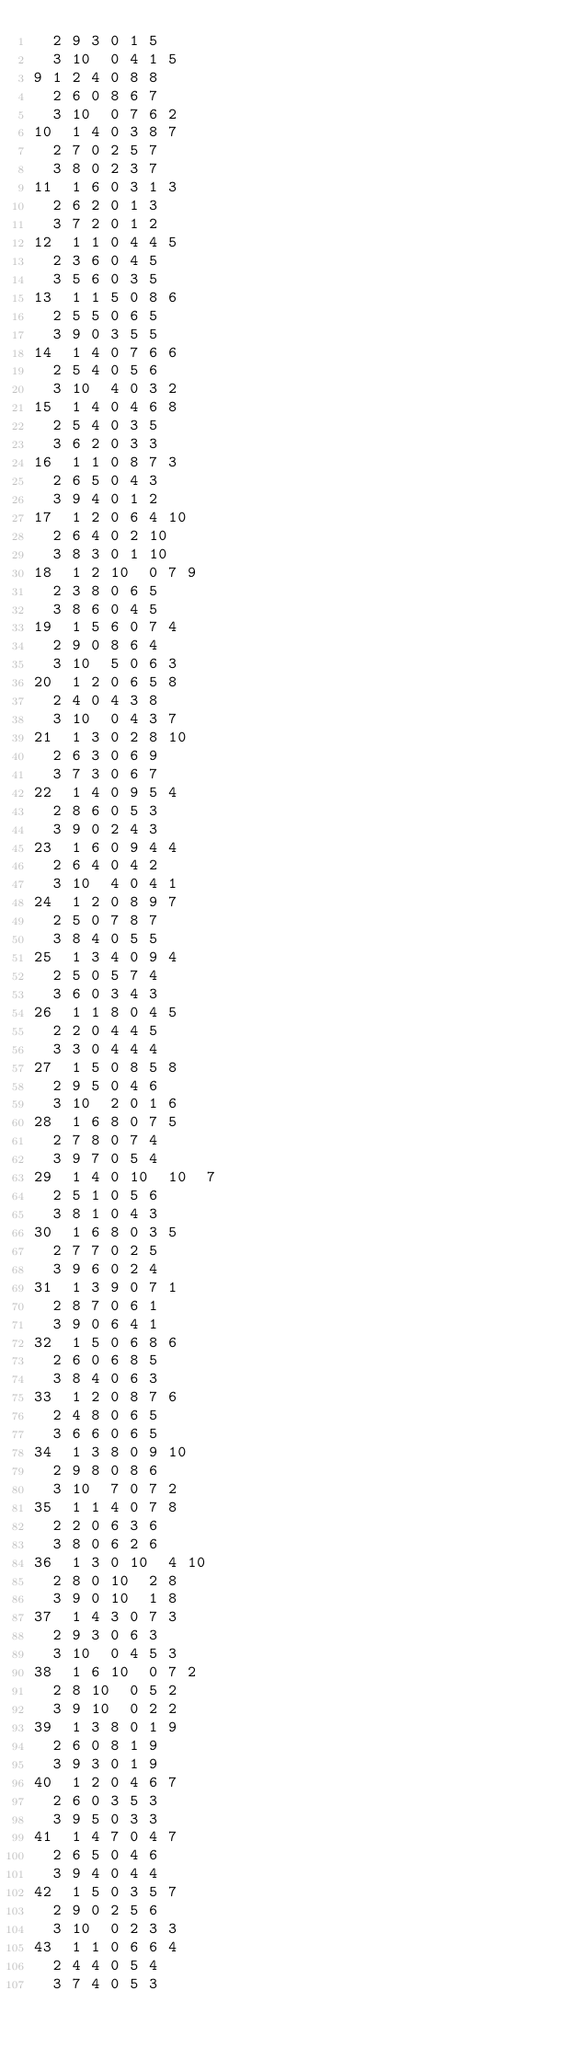<code> <loc_0><loc_0><loc_500><loc_500><_ObjectiveC_>	2	9	3	0	1	5	
	3	10	0	4	1	5	
9	1	2	4	0	8	8	
	2	6	0	8	6	7	
	3	10	0	7	6	2	
10	1	4	0	3	8	7	
	2	7	0	2	5	7	
	3	8	0	2	3	7	
11	1	6	0	3	1	3	
	2	6	2	0	1	3	
	3	7	2	0	1	2	
12	1	1	0	4	4	5	
	2	3	6	0	4	5	
	3	5	6	0	3	5	
13	1	1	5	0	8	6	
	2	5	5	0	6	5	
	3	9	0	3	5	5	
14	1	4	0	7	6	6	
	2	5	4	0	5	6	
	3	10	4	0	3	2	
15	1	4	0	4	6	8	
	2	5	4	0	3	5	
	3	6	2	0	3	3	
16	1	1	0	8	7	3	
	2	6	5	0	4	3	
	3	9	4	0	1	2	
17	1	2	0	6	4	10	
	2	6	4	0	2	10	
	3	8	3	0	1	10	
18	1	2	10	0	7	9	
	2	3	8	0	6	5	
	3	8	6	0	4	5	
19	1	5	6	0	7	4	
	2	9	0	8	6	4	
	3	10	5	0	6	3	
20	1	2	0	6	5	8	
	2	4	0	4	3	8	
	3	10	0	4	3	7	
21	1	3	0	2	8	10	
	2	6	3	0	6	9	
	3	7	3	0	6	7	
22	1	4	0	9	5	4	
	2	8	6	0	5	3	
	3	9	0	2	4	3	
23	1	6	0	9	4	4	
	2	6	4	0	4	2	
	3	10	4	0	4	1	
24	1	2	0	8	9	7	
	2	5	0	7	8	7	
	3	8	4	0	5	5	
25	1	3	4	0	9	4	
	2	5	0	5	7	4	
	3	6	0	3	4	3	
26	1	1	8	0	4	5	
	2	2	0	4	4	5	
	3	3	0	4	4	4	
27	1	5	0	8	5	8	
	2	9	5	0	4	6	
	3	10	2	0	1	6	
28	1	6	8	0	7	5	
	2	7	8	0	7	4	
	3	9	7	0	5	4	
29	1	4	0	10	10	7	
	2	5	1	0	5	6	
	3	8	1	0	4	3	
30	1	6	8	0	3	5	
	2	7	7	0	2	5	
	3	9	6	0	2	4	
31	1	3	9	0	7	1	
	2	8	7	0	6	1	
	3	9	0	6	4	1	
32	1	5	0	6	8	6	
	2	6	0	6	8	5	
	3	8	4	0	6	3	
33	1	2	0	8	7	6	
	2	4	8	0	6	5	
	3	6	6	0	6	5	
34	1	3	8	0	9	10	
	2	9	8	0	8	6	
	3	10	7	0	7	2	
35	1	1	4	0	7	8	
	2	2	0	6	3	6	
	3	8	0	6	2	6	
36	1	3	0	10	4	10	
	2	8	0	10	2	8	
	3	9	0	10	1	8	
37	1	4	3	0	7	3	
	2	9	3	0	6	3	
	3	10	0	4	5	3	
38	1	6	10	0	7	2	
	2	8	10	0	5	2	
	3	9	10	0	2	2	
39	1	3	8	0	1	9	
	2	6	0	8	1	9	
	3	9	3	0	1	9	
40	1	2	0	4	6	7	
	2	6	0	3	5	3	
	3	9	5	0	3	3	
41	1	4	7	0	4	7	
	2	6	5	0	4	6	
	3	9	4	0	4	4	
42	1	5	0	3	5	7	
	2	9	0	2	5	6	
	3	10	0	2	3	3	
43	1	1	0	6	6	4	
	2	4	4	0	5	4	
	3	7	4	0	5	3	</code> 